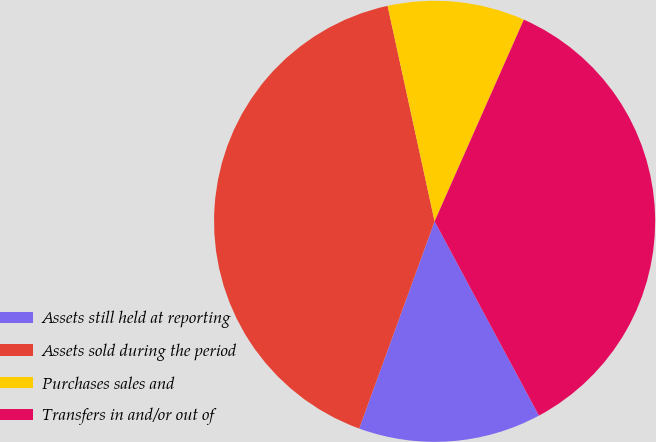Convert chart to OTSL. <chart><loc_0><loc_0><loc_500><loc_500><pie_chart><fcel>Assets still held at reporting<fcel>Assets sold during the period<fcel>Purchases sales and<fcel>Transfers in and/or out of<nl><fcel>13.4%<fcel>41.02%<fcel>10.05%<fcel>35.52%<nl></chart> 